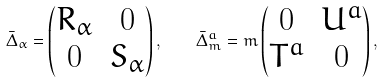<formula> <loc_0><loc_0><loc_500><loc_500>\bar { \Delta } _ { \alpha } = \begin{pmatrix} R _ { \alpha } & 0 \\ 0 & S _ { \alpha } \end{pmatrix} , \quad \bar { \Delta } _ { m } ^ { a } = m \begin{pmatrix} 0 & U ^ { a } \\ T ^ { a } & 0 \end{pmatrix} ,</formula> 